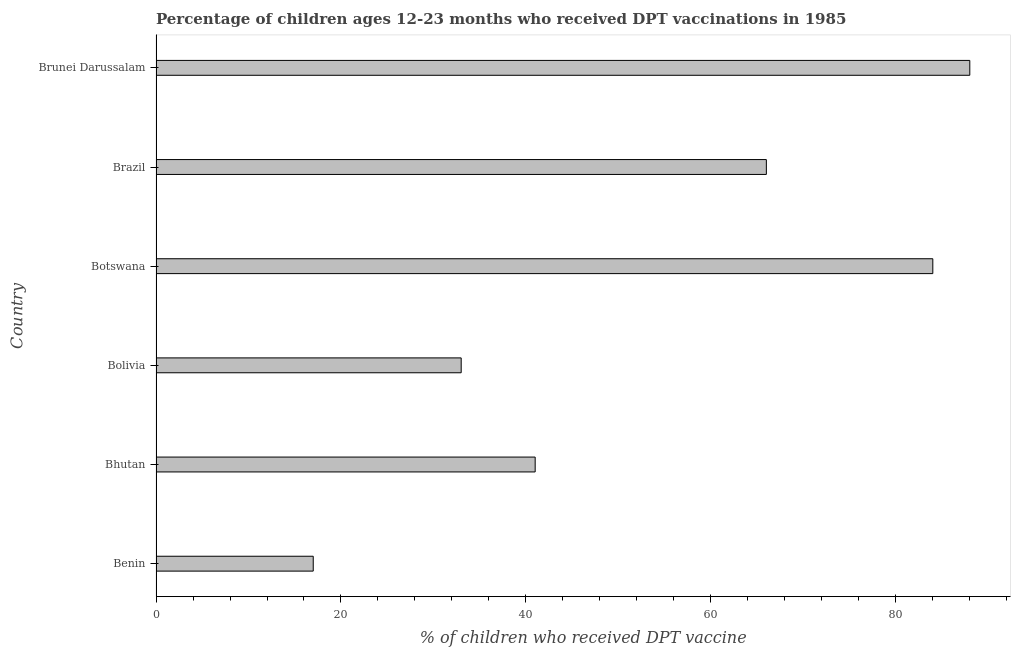What is the title of the graph?
Your answer should be very brief. Percentage of children ages 12-23 months who received DPT vaccinations in 1985. What is the label or title of the X-axis?
Ensure brevity in your answer.  % of children who received DPT vaccine. Across all countries, what is the maximum percentage of children who received dpt vaccine?
Make the answer very short. 88. Across all countries, what is the minimum percentage of children who received dpt vaccine?
Offer a terse response. 17. In which country was the percentage of children who received dpt vaccine maximum?
Offer a very short reply. Brunei Darussalam. In which country was the percentage of children who received dpt vaccine minimum?
Provide a short and direct response. Benin. What is the sum of the percentage of children who received dpt vaccine?
Your answer should be very brief. 329. What is the difference between the percentage of children who received dpt vaccine in Benin and Botswana?
Ensure brevity in your answer.  -67. What is the average percentage of children who received dpt vaccine per country?
Your answer should be very brief. 54.83. What is the median percentage of children who received dpt vaccine?
Your answer should be compact. 53.5. In how many countries, is the percentage of children who received dpt vaccine greater than 52 %?
Keep it short and to the point. 3. What is the ratio of the percentage of children who received dpt vaccine in Bhutan to that in Brunei Darussalam?
Offer a terse response. 0.47. Is the percentage of children who received dpt vaccine in Bolivia less than that in Brazil?
Your response must be concise. Yes. Is the difference between the percentage of children who received dpt vaccine in Benin and Brazil greater than the difference between any two countries?
Your response must be concise. No. What is the difference between the highest and the second highest percentage of children who received dpt vaccine?
Offer a very short reply. 4. In how many countries, is the percentage of children who received dpt vaccine greater than the average percentage of children who received dpt vaccine taken over all countries?
Your answer should be very brief. 3. Are all the bars in the graph horizontal?
Your response must be concise. Yes. How many countries are there in the graph?
Give a very brief answer. 6. What is the % of children who received DPT vaccine of Benin?
Offer a terse response. 17. What is the % of children who received DPT vaccine in Brazil?
Keep it short and to the point. 66. What is the difference between the % of children who received DPT vaccine in Benin and Bhutan?
Keep it short and to the point. -24. What is the difference between the % of children who received DPT vaccine in Benin and Botswana?
Offer a very short reply. -67. What is the difference between the % of children who received DPT vaccine in Benin and Brazil?
Ensure brevity in your answer.  -49. What is the difference between the % of children who received DPT vaccine in Benin and Brunei Darussalam?
Keep it short and to the point. -71. What is the difference between the % of children who received DPT vaccine in Bhutan and Botswana?
Your answer should be compact. -43. What is the difference between the % of children who received DPT vaccine in Bhutan and Brunei Darussalam?
Offer a very short reply. -47. What is the difference between the % of children who received DPT vaccine in Bolivia and Botswana?
Give a very brief answer. -51. What is the difference between the % of children who received DPT vaccine in Bolivia and Brazil?
Make the answer very short. -33. What is the difference between the % of children who received DPT vaccine in Bolivia and Brunei Darussalam?
Make the answer very short. -55. What is the difference between the % of children who received DPT vaccine in Botswana and Brazil?
Your response must be concise. 18. What is the difference between the % of children who received DPT vaccine in Brazil and Brunei Darussalam?
Provide a short and direct response. -22. What is the ratio of the % of children who received DPT vaccine in Benin to that in Bhutan?
Provide a succinct answer. 0.41. What is the ratio of the % of children who received DPT vaccine in Benin to that in Bolivia?
Offer a very short reply. 0.52. What is the ratio of the % of children who received DPT vaccine in Benin to that in Botswana?
Give a very brief answer. 0.2. What is the ratio of the % of children who received DPT vaccine in Benin to that in Brazil?
Provide a succinct answer. 0.26. What is the ratio of the % of children who received DPT vaccine in Benin to that in Brunei Darussalam?
Offer a terse response. 0.19. What is the ratio of the % of children who received DPT vaccine in Bhutan to that in Bolivia?
Keep it short and to the point. 1.24. What is the ratio of the % of children who received DPT vaccine in Bhutan to that in Botswana?
Give a very brief answer. 0.49. What is the ratio of the % of children who received DPT vaccine in Bhutan to that in Brazil?
Ensure brevity in your answer.  0.62. What is the ratio of the % of children who received DPT vaccine in Bhutan to that in Brunei Darussalam?
Your response must be concise. 0.47. What is the ratio of the % of children who received DPT vaccine in Bolivia to that in Botswana?
Offer a terse response. 0.39. What is the ratio of the % of children who received DPT vaccine in Bolivia to that in Brunei Darussalam?
Your response must be concise. 0.38. What is the ratio of the % of children who received DPT vaccine in Botswana to that in Brazil?
Make the answer very short. 1.27. What is the ratio of the % of children who received DPT vaccine in Botswana to that in Brunei Darussalam?
Keep it short and to the point. 0.95. What is the ratio of the % of children who received DPT vaccine in Brazil to that in Brunei Darussalam?
Make the answer very short. 0.75. 